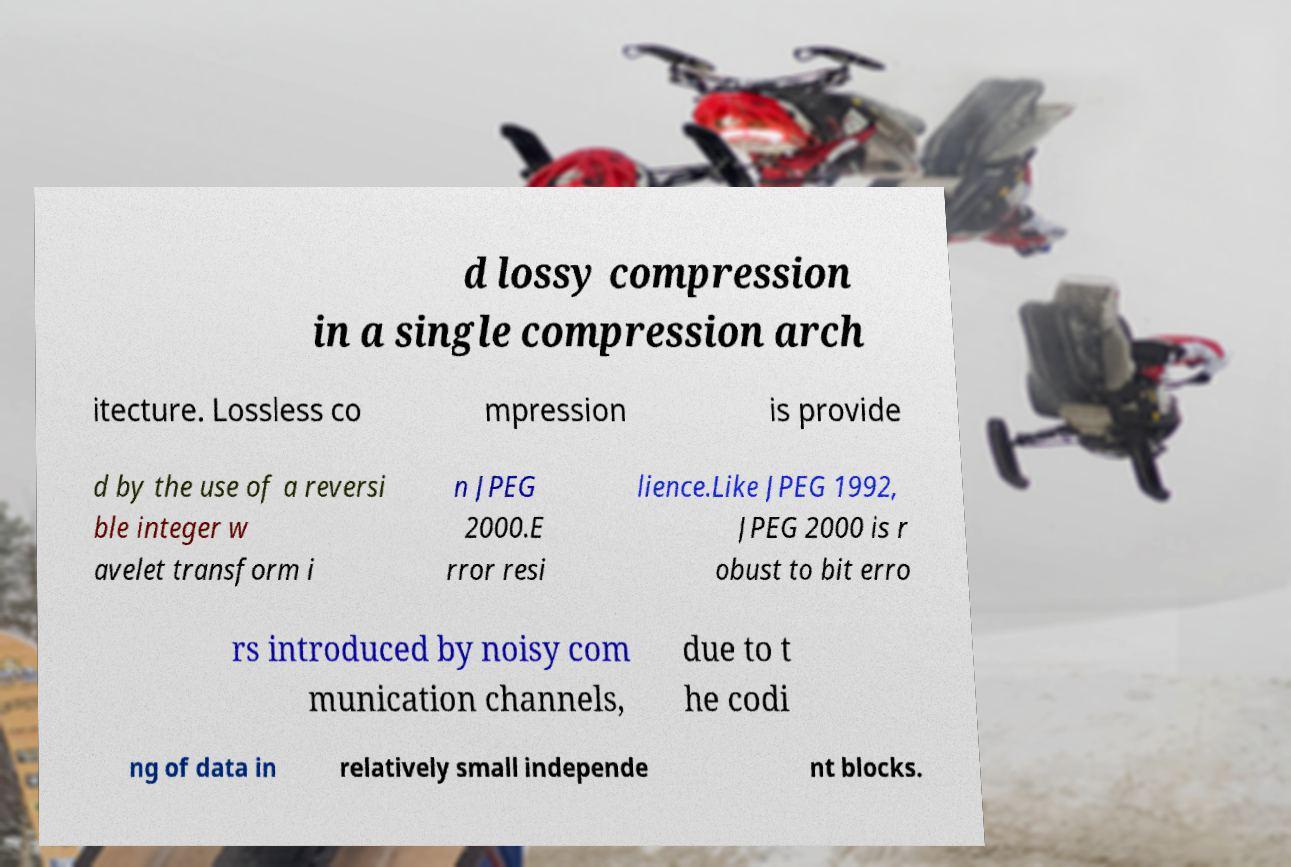Could you assist in decoding the text presented in this image and type it out clearly? d lossy compression in a single compression arch itecture. Lossless co mpression is provide d by the use of a reversi ble integer w avelet transform i n JPEG 2000.E rror resi lience.Like JPEG 1992, JPEG 2000 is r obust to bit erro rs introduced by noisy com munication channels, due to t he codi ng of data in relatively small independe nt blocks. 